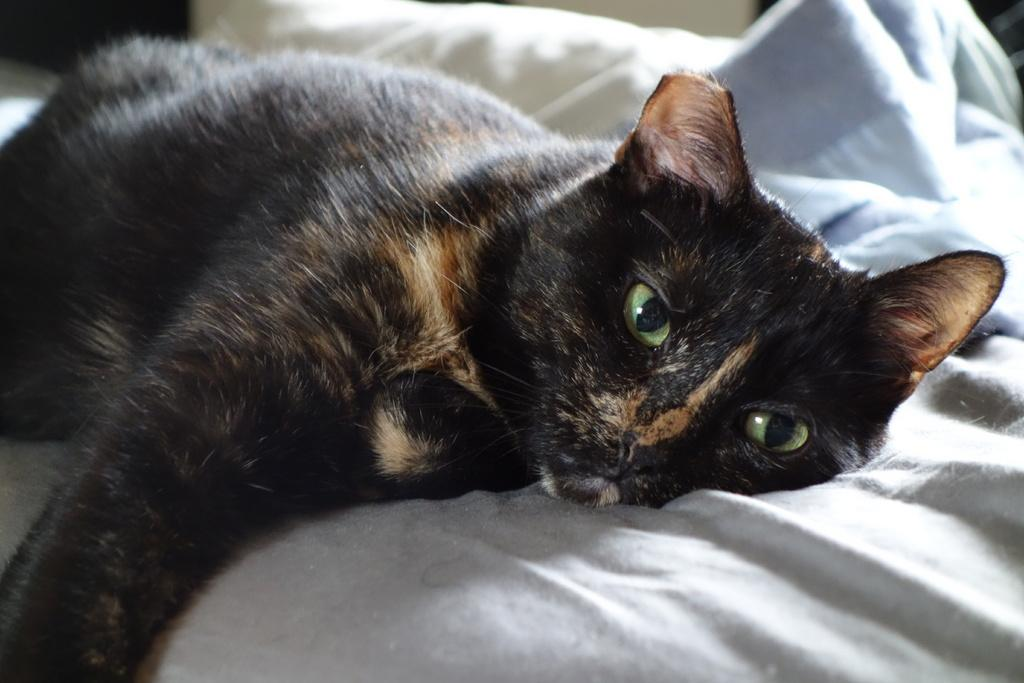What type of animal is in the image? There is a black color cat in the image. Where is the cat located? The cat is on the bed. Are there any birds performing magic tricks in the image? There are no birds or magic tricks present in the image; it features a black color cat on the bed. 